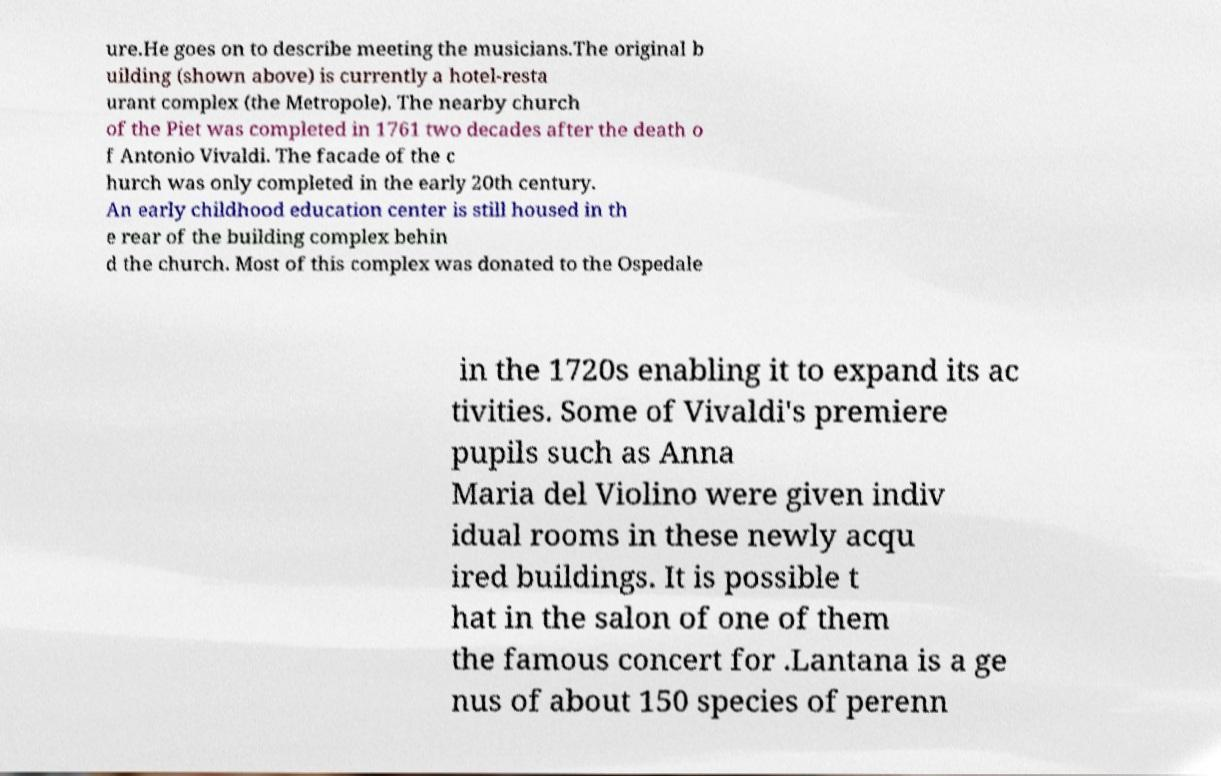I need the written content from this picture converted into text. Can you do that? ure.He goes on to describe meeting the musicians.The original b uilding (shown above) is currently a hotel-resta urant complex (the Metropole). The nearby church of the Piet was completed in 1761 two decades after the death o f Antonio Vivaldi. The facade of the c hurch was only completed in the early 20th century. An early childhood education center is still housed in th e rear of the building complex behin d the church. Most of this complex was donated to the Ospedale in the 1720s enabling it to expand its ac tivities. Some of Vivaldi's premiere pupils such as Anna Maria del Violino were given indiv idual rooms in these newly acqu ired buildings. It is possible t hat in the salon of one of them the famous concert for .Lantana is a ge nus of about 150 species of perenn 